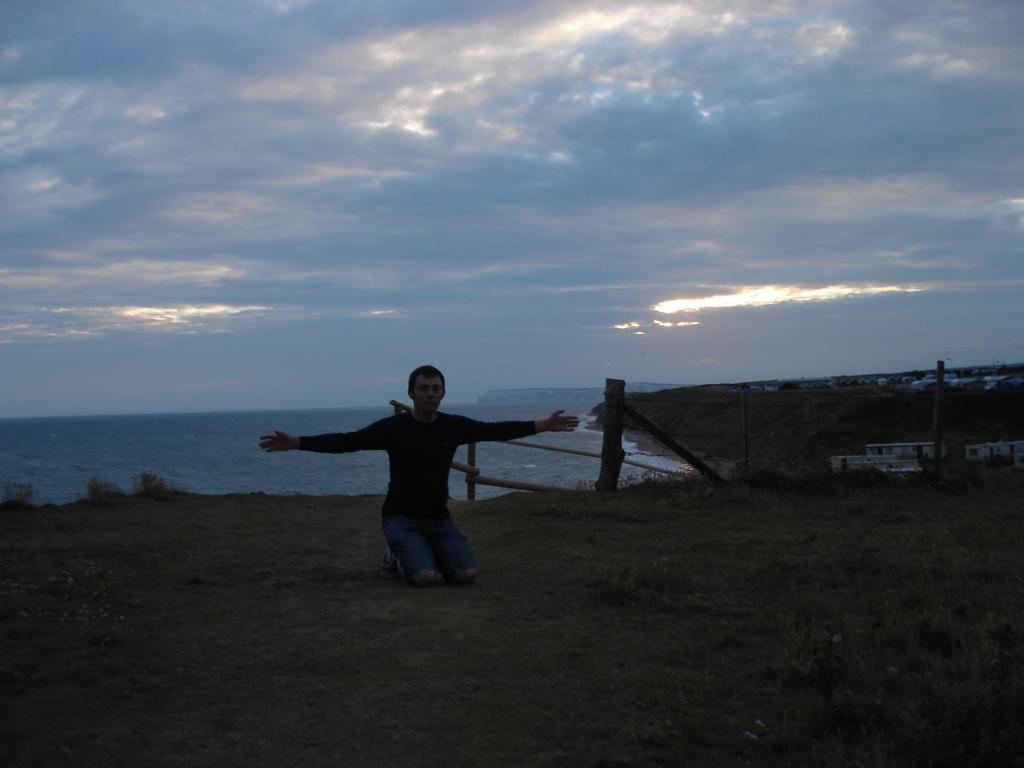Who or what is the main subject in the image? There is a person in the image. What can be seen in the distance behind the person? There are houses and trees in the background of the image. What natural element is visible in the image? There is water visible in the image. What is the color of the sky in the image? The sky is blue and white in color. What type of patch is sewn onto the person's clothing in the image? There is no patch visible on the person's clothing in the image. What items are on the list that the person is holding in the image? The person is not holding a list in the image. What is the occasion being celebrated in the image? There is no indication of a birthday or any other celebration in the image. 